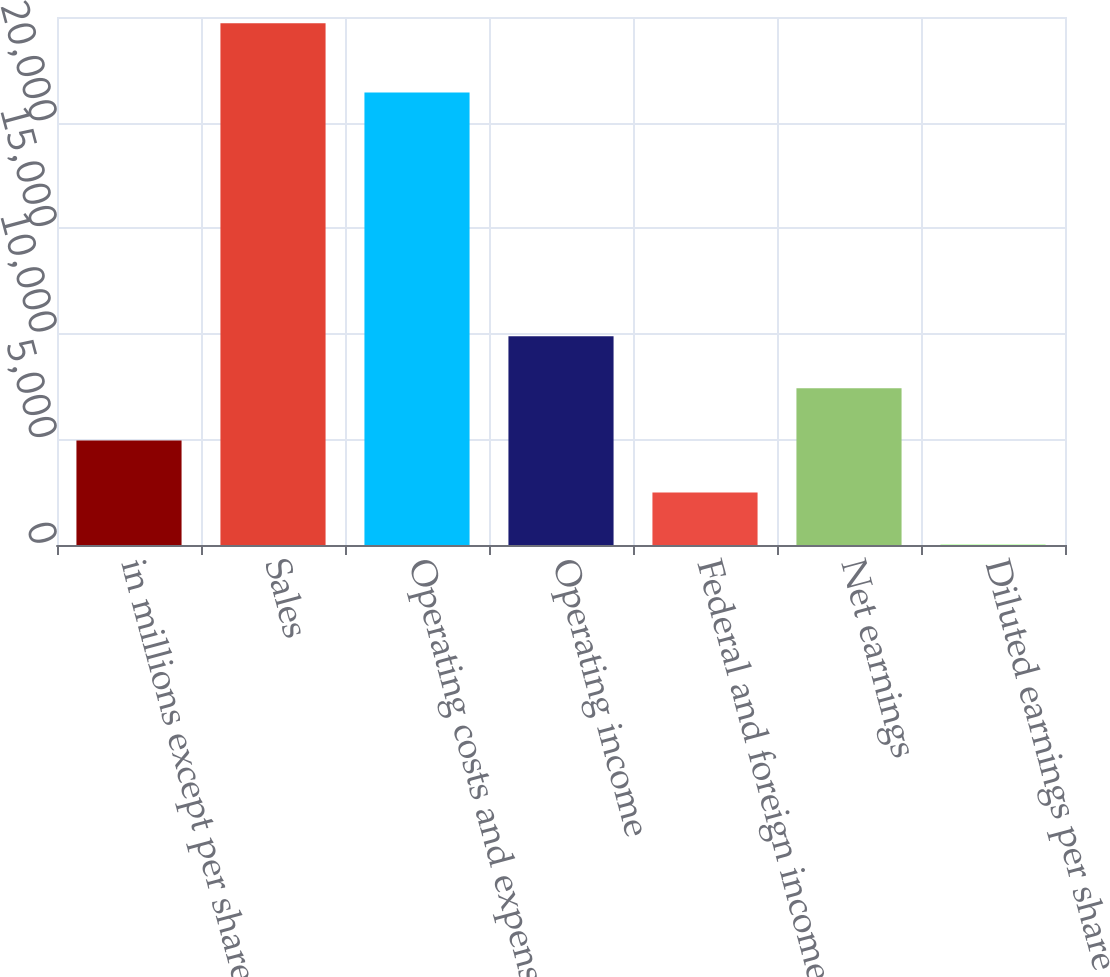Convert chart. <chart><loc_0><loc_0><loc_500><loc_500><bar_chart><fcel>in millions except per share<fcel>Sales<fcel>Operating costs and expenses<fcel>Operating income<fcel>Federal and foreign income tax<fcel>Net earnings<fcel>Diluted earnings per share<nl><fcel>4950.26<fcel>24706<fcel>21429<fcel>9889.2<fcel>2480.79<fcel>7419.73<fcel>11.32<nl></chart> 